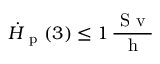<formula> <loc_0><loc_0><loc_500><loc_500>\ D o t { H } _ { p } ( 3 ) \leq 1 \, \frac { S v } { h }</formula> 